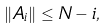Convert formula to latex. <formula><loc_0><loc_0><loc_500><loc_500>\| A _ { i } \| \leq N - i ,</formula> 